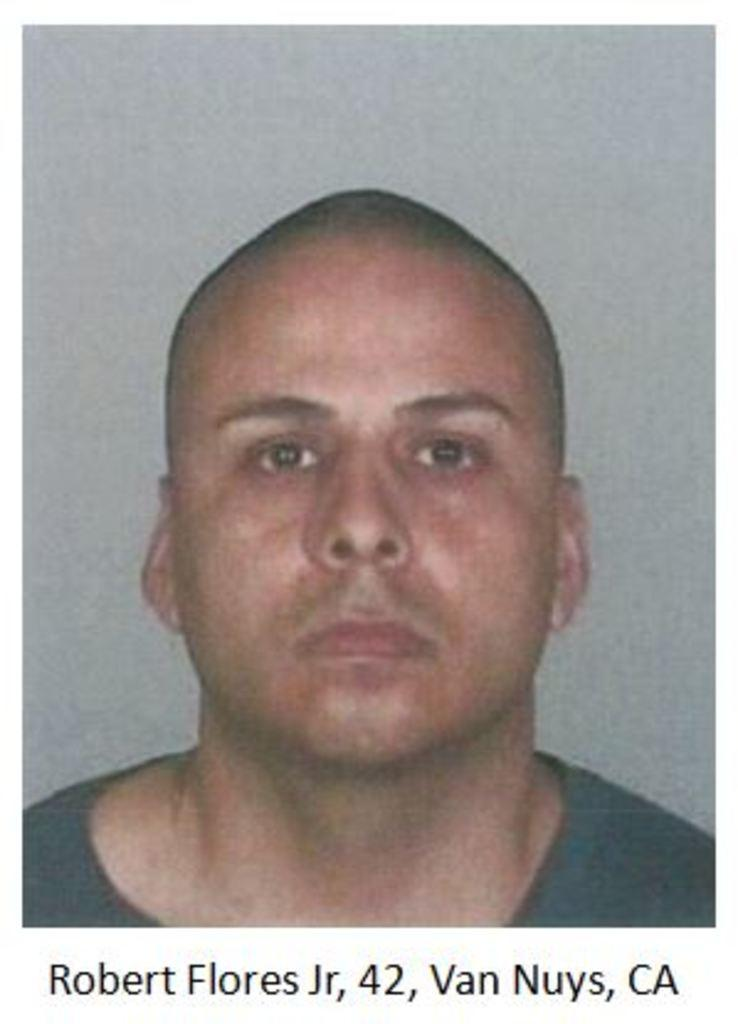What is the main subject of the image? The main subject of the image is a person's face. Can you describe the person's appearance? The person has a bald head. What else is present in the image besides the person's face? There is text written below the face. What type of soap is being advertised in the image? There is no soap or advertisement present in the image; it features a person's face with text below it. 